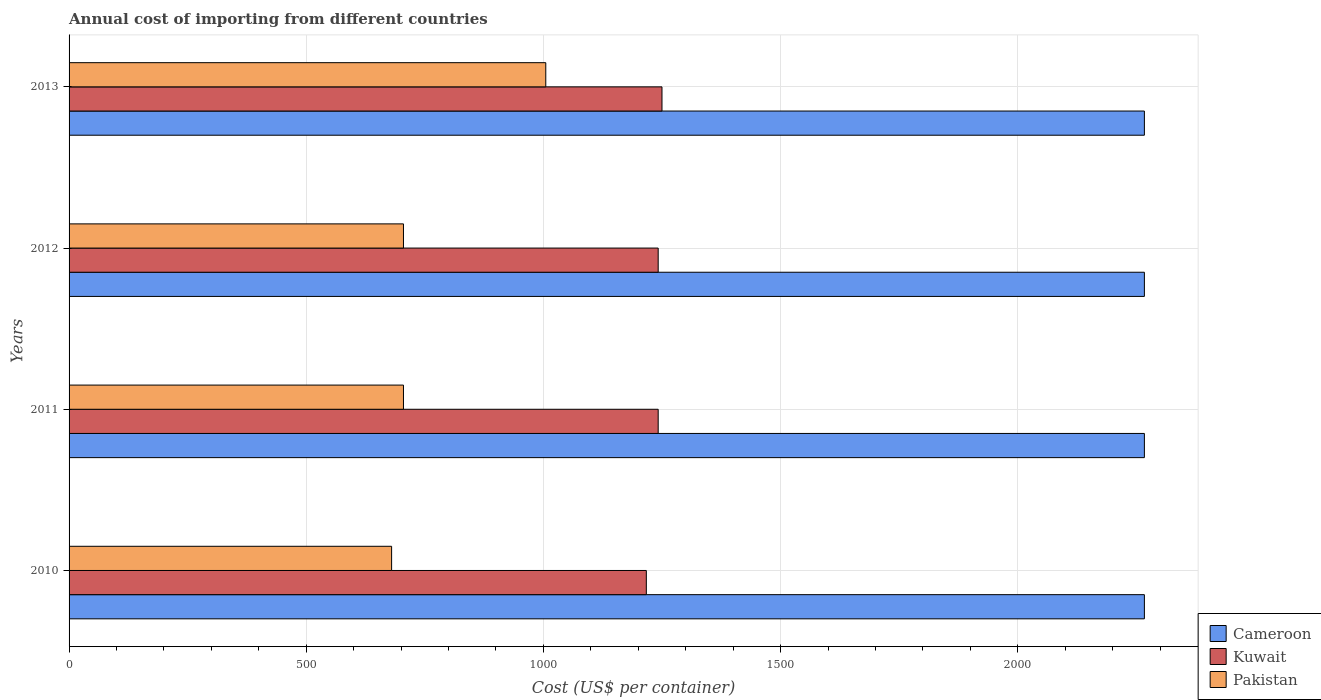How many different coloured bars are there?
Make the answer very short. 3. Are the number of bars per tick equal to the number of legend labels?
Offer a terse response. Yes. How many bars are there on the 2nd tick from the top?
Offer a very short reply. 3. What is the label of the 3rd group of bars from the top?
Your response must be concise. 2011. What is the total annual cost of importing in Cameroon in 2010?
Your answer should be very brief. 2267. Across all years, what is the maximum total annual cost of importing in Pakistan?
Offer a very short reply. 1005. Across all years, what is the minimum total annual cost of importing in Kuwait?
Provide a succinct answer. 1217. In which year was the total annual cost of importing in Pakistan maximum?
Offer a terse response. 2013. What is the total total annual cost of importing in Kuwait in the graph?
Your response must be concise. 4951. What is the difference between the total annual cost of importing in Kuwait in 2010 and that in 2013?
Ensure brevity in your answer.  -33. What is the difference between the total annual cost of importing in Pakistan in 2010 and the total annual cost of importing in Kuwait in 2011?
Provide a succinct answer. -562. What is the average total annual cost of importing in Cameroon per year?
Provide a short and direct response. 2267. In the year 2012, what is the difference between the total annual cost of importing in Kuwait and total annual cost of importing in Cameroon?
Make the answer very short. -1025. What is the ratio of the total annual cost of importing in Cameroon in 2011 to that in 2013?
Keep it short and to the point. 1. Is the difference between the total annual cost of importing in Kuwait in 2010 and 2011 greater than the difference between the total annual cost of importing in Cameroon in 2010 and 2011?
Your answer should be compact. No. What is the difference between the highest and the second highest total annual cost of importing in Kuwait?
Your answer should be compact. 8. What is the difference between the highest and the lowest total annual cost of importing in Pakistan?
Make the answer very short. 325. Is the sum of the total annual cost of importing in Kuwait in 2011 and 2013 greater than the maximum total annual cost of importing in Pakistan across all years?
Offer a terse response. Yes. What does the 3rd bar from the top in 2013 represents?
Offer a terse response. Cameroon. What does the 3rd bar from the bottom in 2012 represents?
Offer a terse response. Pakistan. Is it the case that in every year, the sum of the total annual cost of importing in Pakistan and total annual cost of importing in Cameroon is greater than the total annual cost of importing in Kuwait?
Provide a succinct answer. Yes. Are all the bars in the graph horizontal?
Provide a short and direct response. Yes. How many years are there in the graph?
Offer a very short reply. 4. What is the difference between two consecutive major ticks on the X-axis?
Offer a terse response. 500. Does the graph contain any zero values?
Ensure brevity in your answer.  No. How many legend labels are there?
Make the answer very short. 3. How are the legend labels stacked?
Provide a succinct answer. Vertical. What is the title of the graph?
Make the answer very short. Annual cost of importing from different countries. What is the label or title of the X-axis?
Give a very brief answer. Cost (US$ per container). What is the Cost (US$ per container) of Cameroon in 2010?
Give a very brief answer. 2267. What is the Cost (US$ per container) of Kuwait in 2010?
Offer a terse response. 1217. What is the Cost (US$ per container) of Pakistan in 2010?
Keep it short and to the point. 680. What is the Cost (US$ per container) of Cameroon in 2011?
Offer a very short reply. 2267. What is the Cost (US$ per container) of Kuwait in 2011?
Provide a short and direct response. 1242. What is the Cost (US$ per container) in Pakistan in 2011?
Your answer should be compact. 705. What is the Cost (US$ per container) of Cameroon in 2012?
Ensure brevity in your answer.  2267. What is the Cost (US$ per container) of Kuwait in 2012?
Give a very brief answer. 1242. What is the Cost (US$ per container) in Pakistan in 2012?
Offer a terse response. 705. What is the Cost (US$ per container) of Cameroon in 2013?
Make the answer very short. 2267. What is the Cost (US$ per container) in Kuwait in 2013?
Your answer should be very brief. 1250. What is the Cost (US$ per container) of Pakistan in 2013?
Offer a very short reply. 1005. Across all years, what is the maximum Cost (US$ per container) of Cameroon?
Provide a short and direct response. 2267. Across all years, what is the maximum Cost (US$ per container) of Kuwait?
Give a very brief answer. 1250. Across all years, what is the maximum Cost (US$ per container) of Pakistan?
Your answer should be very brief. 1005. Across all years, what is the minimum Cost (US$ per container) of Cameroon?
Your answer should be compact. 2267. Across all years, what is the minimum Cost (US$ per container) in Kuwait?
Provide a short and direct response. 1217. Across all years, what is the minimum Cost (US$ per container) of Pakistan?
Your response must be concise. 680. What is the total Cost (US$ per container) in Cameroon in the graph?
Your answer should be very brief. 9068. What is the total Cost (US$ per container) of Kuwait in the graph?
Your response must be concise. 4951. What is the total Cost (US$ per container) of Pakistan in the graph?
Your answer should be very brief. 3095. What is the difference between the Cost (US$ per container) in Kuwait in 2010 and that in 2011?
Provide a short and direct response. -25. What is the difference between the Cost (US$ per container) in Pakistan in 2010 and that in 2011?
Keep it short and to the point. -25. What is the difference between the Cost (US$ per container) of Kuwait in 2010 and that in 2012?
Make the answer very short. -25. What is the difference between the Cost (US$ per container) of Cameroon in 2010 and that in 2013?
Ensure brevity in your answer.  0. What is the difference between the Cost (US$ per container) in Kuwait in 2010 and that in 2013?
Provide a short and direct response. -33. What is the difference between the Cost (US$ per container) in Pakistan in 2010 and that in 2013?
Your response must be concise. -325. What is the difference between the Cost (US$ per container) in Kuwait in 2011 and that in 2012?
Make the answer very short. 0. What is the difference between the Cost (US$ per container) of Cameroon in 2011 and that in 2013?
Provide a succinct answer. 0. What is the difference between the Cost (US$ per container) of Pakistan in 2011 and that in 2013?
Ensure brevity in your answer.  -300. What is the difference between the Cost (US$ per container) in Cameroon in 2012 and that in 2013?
Your answer should be compact. 0. What is the difference between the Cost (US$ per container) of Kuwait in 2012 and that in 2013?
Keep it short and to the point. -8. What is the difference between the Cost (US$ per container) in Pakistan in 2012 and that in 2013?
Ensure brevity in your answer.  -300. What is the difference between the Cost (US$ per container) of Cameroon in 2010 and the Cost (US$ per container) of Kuwait in 2011?
Your response must be concise. 1025. What is the difference between the Cost (US$ per container) in Cameroon in 2010 and the Cost (US$ per container) in Pakistan in 2011?
Provide a succinct answer. 1562. What is the difference between the Cost (US$ per container) of Kuwait in 2010 and the Cost (US$ per container) of Pakistan in 2011?
Keep it short and to the point. 512. What is the difference between the Cost (US$ per container) in Cameroon in 2010 and the Cost (US$ per container) in Kuwait in 2012?
Your answer should be compact. 1025. What is the difference between the Cost (US$ per container) in Cameroon in 2010 and the Cost (US$ per container) in Pakistan in 2012?
Provide a succinct answer. 1562. What is the difference between the Cost (US$ per container) of Kuwait in 2010 and the Cost (US$ per container) of Pakistan in 2012?
Your answer should be compact. 512. What is the difference between the Cost (US$ per container) in Cameroon in 2010 and the Cost (US$ per container) in Kuwait in 2013?
Provide a succinct answer. 1017. What is the difference between the Cost (US$ per container) of Cameroon in 2010 and the Cost (US$ per container) of Pakistan in 2013?
Make the answer very short. 1262. What is the difference between the Cost (US$ per container) in Kuwait in 2010 and the Cost (US$ per container) in Pakistan in 2013?
Offer a very short reply. 212. What is the difference between the Cost (US$ per container) of Cameroon in 2011 and the Cost (US$ per container) of Kuwait in 2012?
Provide a short and direct response. 1025. What is the difference between the Cost (US$ per container) in Cameroon in 2011 and the Cost (US$ per container) in Pakistan in 2012?
Your response must be concise. 1562. What is the difference between the Cost (US$ per container) in Kuwait in 2011 and the Cost (US$ per container) in Pakistan in 2012?
Provide a short and direct response. 537. What is the difference between the Cost (US$ per container) in Cameroon in 2011 and the Cost (US$ per container) in Kuwait in 2013?
Provide a short and direct response. 1017. What is the difference between the Cost (US$ per container) of Cameroon in 2011 and the Cost (US$ per container) of Pakistan in 2013?
Give a very brief answer. 1262. What is the difference between the Cost (US$ per container) in Kuwait in 2011 and the Cost (US$ per container) in Pakistan in 2013?
Your response must be concise. 237. What is the difference between the Cost (US$ per container) of Cameroon in 2012 and the Cost (US$ per container) of Kuwait in 2013?
Your answer should be compact. 1017. What is the difference between the Cost (US$ per container) of Cameroon in 2012 and the Cost (US$ per container) of Pakistan in 2013?
Your answer should be very brief. 1262. What is the difference between the Cost (US$ per container) of Kuwait in 2012 and the Cost (US$ per container) of Pakistan in 2013?
Your answer should be compact. 237. What is the average Cost (US$ per container) of Cameroon per year?
Make the answer very short. 2267. What is the average Cost (US$ per container) of Kuwait per year?
Make the answer very short. 1237.75. What is the average Cost (US$ per container) of Pakistan per year?
Your response must be concise. 773.75. In the year 2010, what is the difference between the Cost (US$ per container) of Cameroon and Cost (US$ per container) of Kuwait?
Keep it short and to the point. 1050. In the year 2010, what is the difference between the Cost (US$ per container) in Cameroon and Cost (US$ per container) in Pakistan?
Make the answer very short. 1587. In the year 2010, what is the difference between the Cost (US$ per container) in Kuwait and Cost (US$ per container) in Pakistan?
Provide a short and direct response. 537. In the year 2011, what is the difference between the Cost (US$ per container) in Cameroon and Cost (US$ per container) in Kuwait?
Give a very brief answer. 1025. In the year 2011, what is the difference between the Cost (US$ per container) in Cameroon and Cost (US$ per container) in Pakistan?
Your response must be concise. 1562. In the year 2011, what is the difference between the Cost (US$ per container) in Kuwait and Cost (US$ per container) in Pakistan?
Keep it short and to the point. 537. In the year 2012, what is the difference between the Cost (US$ per container) of Cameroon and Cost (US$ per container) of Kuwait?
Ensure brevity in your answer.  1025. In the year 2012, what is the difference between the Cost (US$ per container) in Cameroon and Cost (US$ per container) in Pakistan?
Make the answer very short. 1562. In the year 2012, what is the difference between the Cost (US$ per container) of Kuwait and Cost (US$ per container) of Pakistan?
Make the answer very short. 537. In the year 2013, what is the difference between the Cost (US$ per container) in Cameroon and Cost (US$ per container) in Kuwait?
Keep it short and to the point. 1017. In the year 2013, what is the difference between the Cost (US$ per container) in Cameroon and Cost (US$ per container) in Pakistan?
Ensure brevity in your answer.  1262. In the year 2013, what is the difference between the Cost (US$ per container) of Kuwait and Cost (US$ per container) of Pakistan?
Give a very brief answer. 245. What is the ratio of the Cost (US$ per container) of Kuwait in 2010 to that in 2011?
Give a very brief answer. 0.98. What is the ratio of the Cost (US$ per container) in Pakistan in 2010 to that in 2011?
Your response must be concise. 0.96. What is the ratio of the Cost (US$ per container) of Cameroon in 2010 to that in 2012?
Provide a short and direct response. 1. What is the ratio of the Cost (US$ per container) of Kuwait in 2010 to that in 2012?
Give a very brief answer. 0.98. What is the ratio of the Cost (US$ per container) in Pakistan in 2010 to that in 2012?
Your response must be concise. 0.96. What is the ratio of the Cost (US$ per container) of Kuwait in 2010 to that in 2013?
Your answer should be compact. 0.97. What is the ratio of the Cost (US$ per container) of Pakistan in 2010 to that in 2013?
Your answer should be compact. 0.68. What is the ratio of the Cost (US$ per container) of Cameroon in 2011 to that in 2012?
Give a very brief answer. 1. What is the ratio of the Cost (US$ per container) of Kuwait in 2011 to that in 2012?
Your answer should be very brief. 1. What is the ratio of the Cost (US$ per container) of Cameroon in 2011 to that in 2013?
Keep it short and to the point. 1. What is the ratio of the Cost (US$ per container) of Kuwait in 2011 to that in 2013?
Provide a succinct answer. 0.99. What is the ratio of the Cost (US$ per container) of Pakistan in 2011 to that in 2013?
Your response must be concise. 0.7. What is the ratio of the Cost (US$ per container) of Pakistan in 2012 to that in 2013?
Keep it short and to the point. 0.7. What is the difference between the highest and the second highest Cost (US$ per container) of Pakistan?
Your answer should be very brief. 300. What is the difference between the highest and the lowest Cost (US$ per container) in Kuwait?
Your answer should be compact. 33. What is the difference between the highest and the lowest Cost (US$ per container) in Pakistan?
Your answer should be compact. 325. 